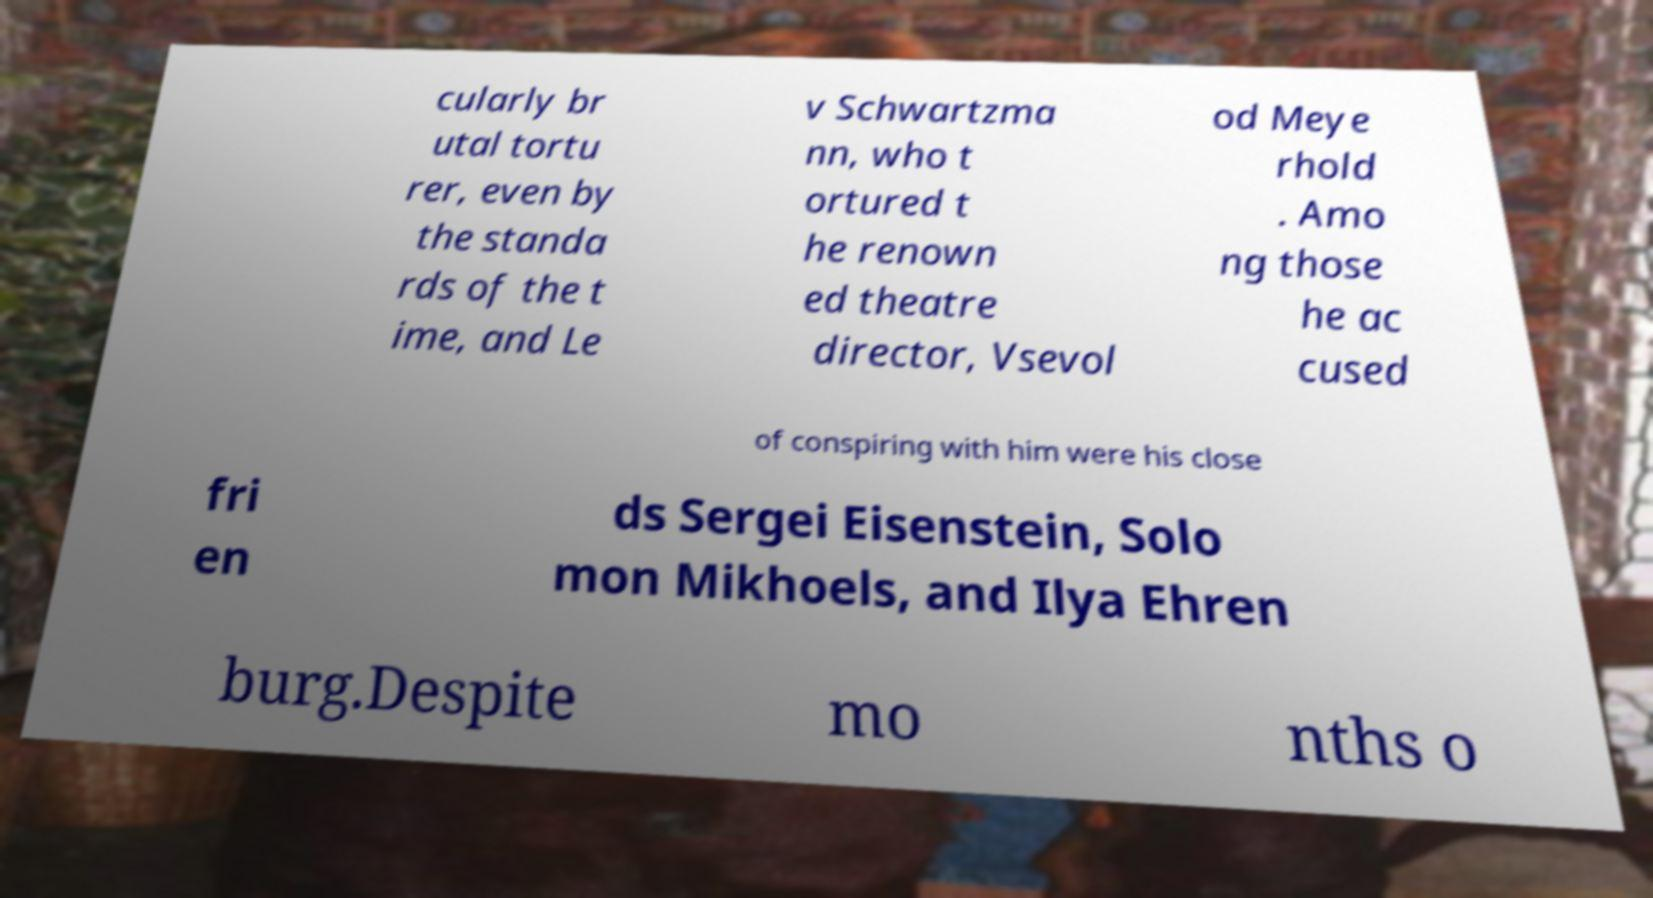Please identify and transcribe the text found in this image. cularly br utal tortu rer, even by the standa rds of the t ime, and Le v Schwartzma nn, who t ortured t he renown ed theatre director, Vsevol od Meye rhold . Amo ng those he ac cused of conspiring with him were his close fri en ds Sergei Eisenstein, Solo mon Mikhoels, and Ilya Ehren burg.Despite mo nths o 